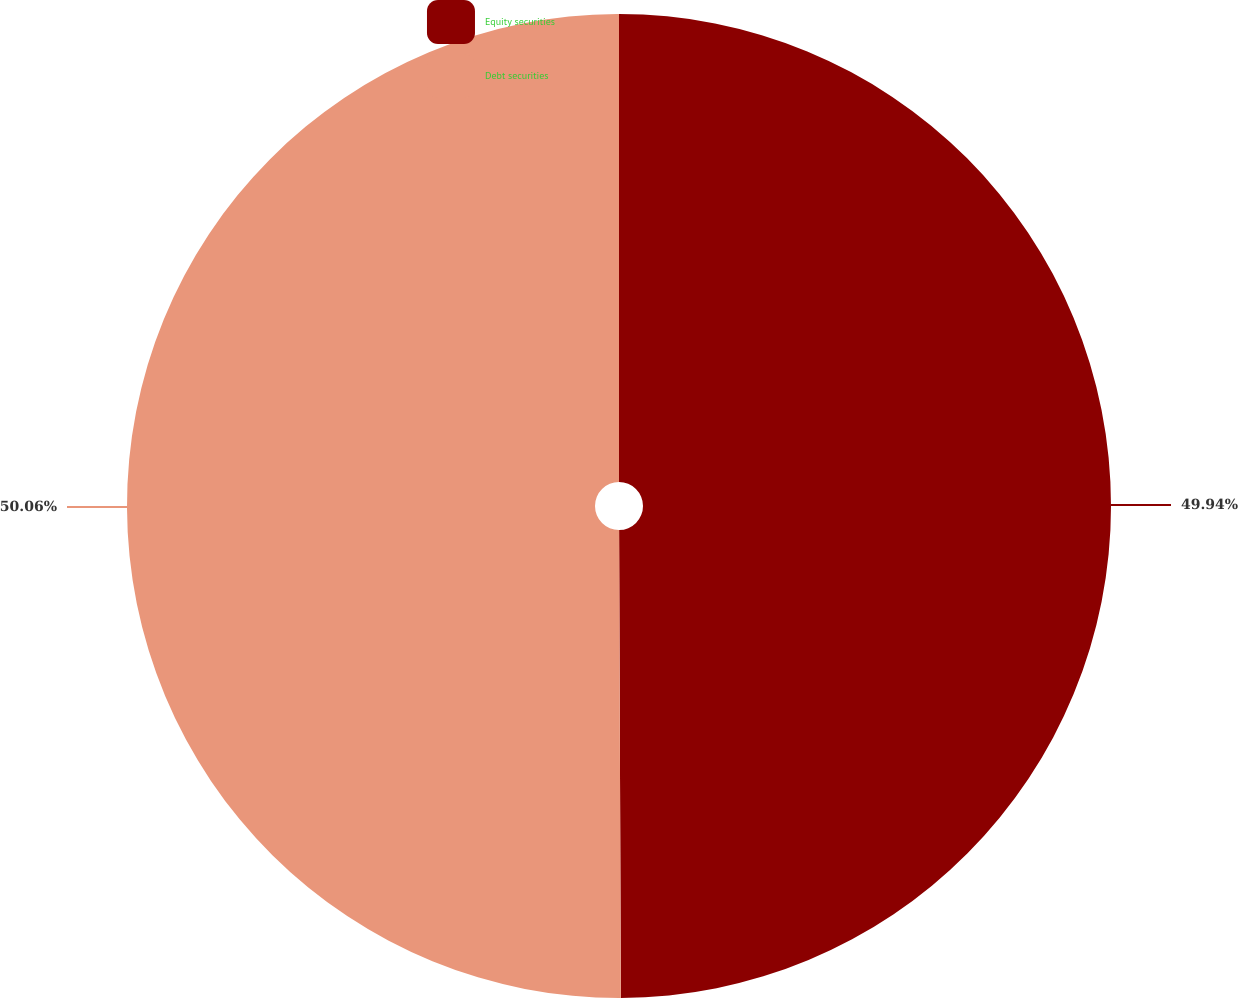<chart> <loc_0><loc_0><loc_500><loc_500><pie_chart><fcel>Equity securities<fcel>Debt securities<nl><fcel>49.94%<fcel>50.06%<nl></chart> 